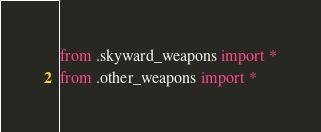<code> <loc_0><loc_0><loc_500><loc_500><_Python_>from .skyward_weapons import *
from .other_weapons import *
</code> 